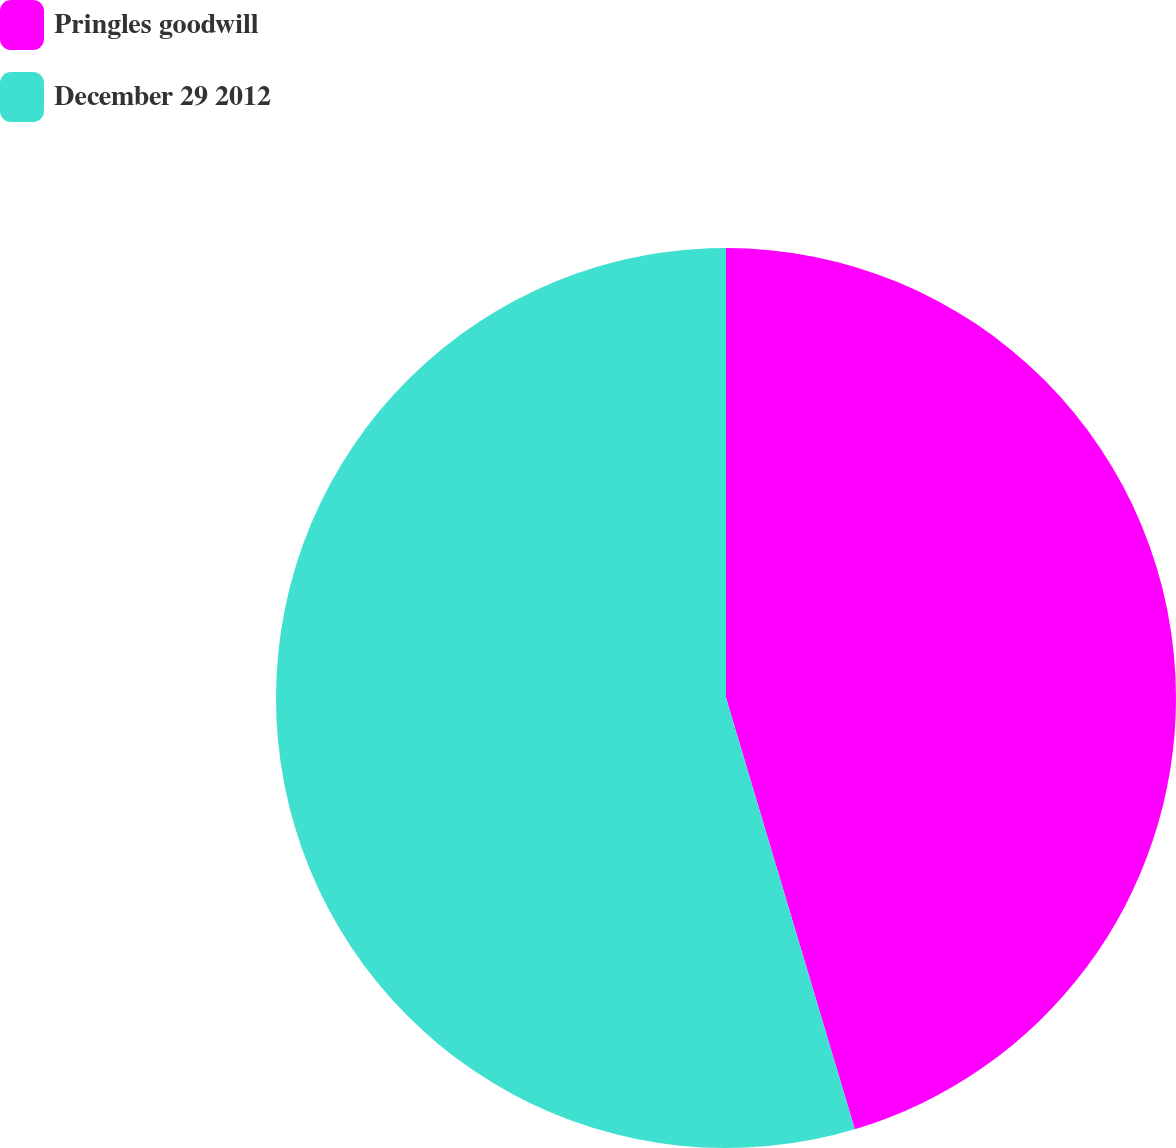<chart> <loc_0><loc_0><loc_500><loc_500><pie_chart><fcel>Pringles goodwill<fcel>December 29 2012<nl><fcel>45.38%<fcel>54.62%<nl></chart> 